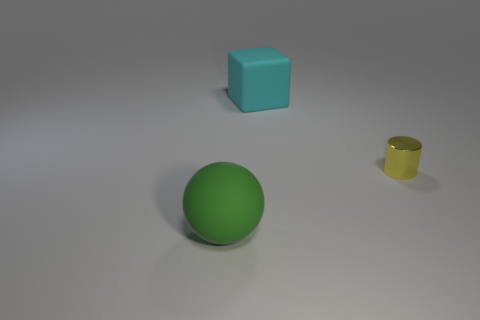Is the number of yellow things greater than the number of rubber things? No, the number of yellow things is not greater than the number of rubber things in the image. The image displays a single yellow object, which appears to be a yellow cup, while there are two objects that could be made of rubber - a green ball and a cyan cube - assuming common color-material associations. 